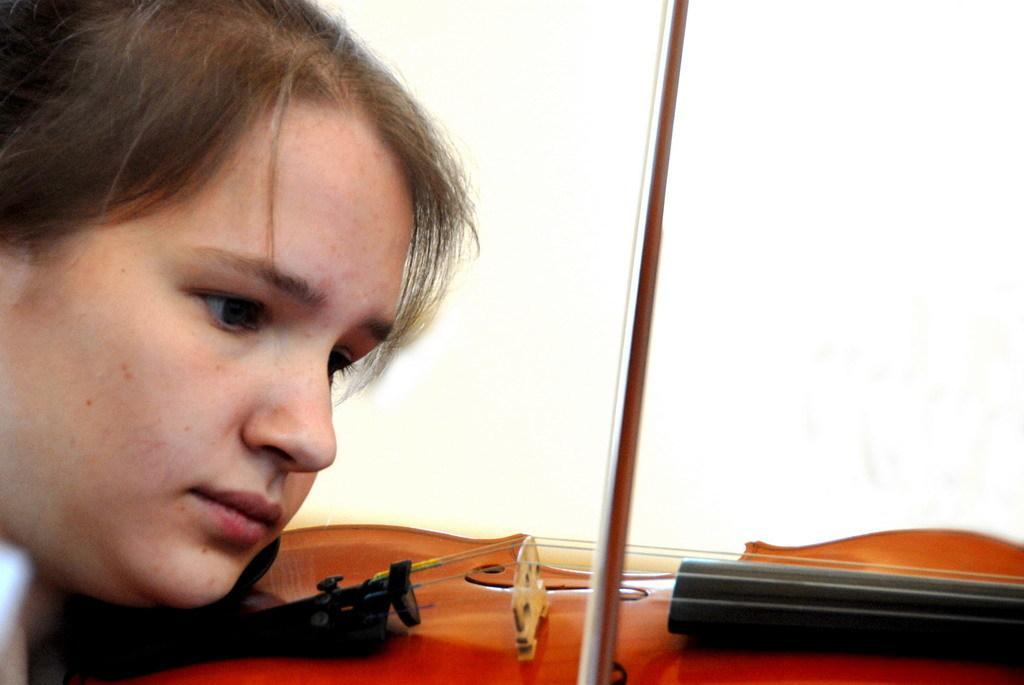Describe this image in one or two sentences. In this image, we can see a woman playing violin. In the background, we can see white color. 